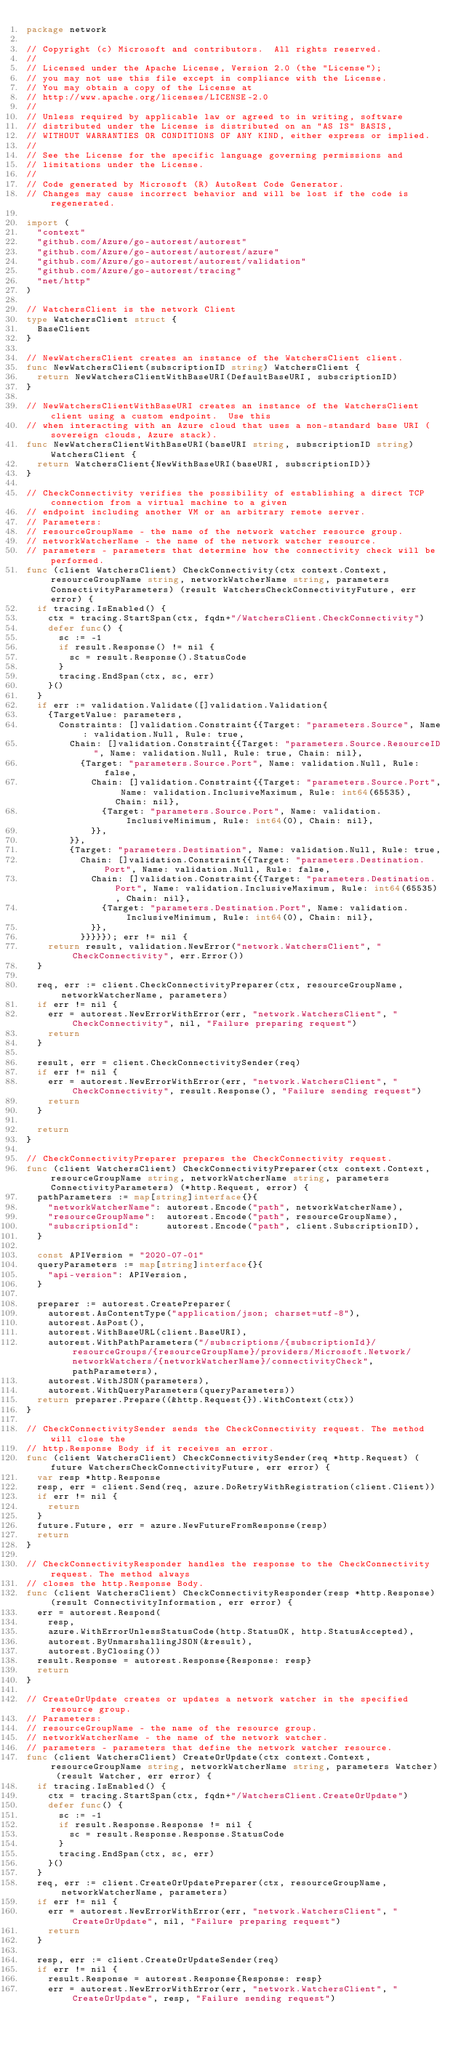<code> <loc_0><loc_0><loc_500><loc_500><_Go_>package network

// Copyright (c) Microsoft and contributors.  All rights reserved.
//
// Licensed under the Apache License, Version 2.0 (the "License");
// you may not use this file except in compliance with the License.
// You may obtain a copy of the License at
// http://www.apache.org/licenses/LICENSE-2.0
//
// Unless required by applicable law or agreed to in writing, software
// distributed under the License is distributed on an "AS IS" BASIS,
// WITHOUT WARRANTIES OR CONDITIONS OF ANY KIND, either express or implied.
//
// See the License for the specific language governing permissions and
// limitations under the License.
//
// Code generated by Microsoft (R) AutoRest Code Generator.
// Changes may cause incorrect behavior and will be lost if the code is regenerated.

import (
	"context"
	"github.com/Azure/go-autorest/autorest"
	"github.com/Azure/go-autorest/autorest/azure"
	"github.com/Azure/go-autorest/autorest/validation"
	"github.com/Azure/go-autorest/tracing"
	"net/http"
)

// WatchersClient is the network Client
type WatchersClient struct {
	BaseClient
}

// NewWatchersClient creates an instance of the WatchersClient client.
func NewWatchersClient(subscriptionID string) WatchersClient {
	return NewWatchersClientWithBaseURI(DefaultBaseURI, subscriptionID)
}

// NewWatchersClientWithBaseURI creates an instance of the WatchersClient client using a custom endpoint.  Use this
// when interacting with an Azure cloud that uses a non-standard base URI (sovereign clouds, Azure stack).
func NewWatchersClientWithBaseURI(baseURI string, subscriptionID string) WatchersClient {
	return WatchersClient{NewWithBaseURI(baseURI, subscriptionID)}
}

// CheckConnectivity verifies the possibility of establishing a direct TCP connection from a virtual machine to a given
// endpoint including another VM or an arbitrary remote server.
// Parameters:
// resourceGroupName - the name of the network watcher resource group.
// networkWatcherName - the name of the network watcher resource.
// parameters - parameters that determine how the connectivity check will be performed.
func (client WatchersClient) CheckConnectivity(ctx context.Context, resourceGroupName string, networkWatcherName string, parameters ConnectivityParameters) (result WatchersCheckConnectivityFuture, err error) {
	if tracing.IsEnabled() {
		ctx = tracing.StartSpan(ctx, fqdn+"/WatchersClient.CheckConnectivity")
		defer func() {
			sc := -1
			if result.Response() != nil {
				sc = result.Response().StatusCode
			}
			tracing.EndSpan(ctx, sc, err)
		}()
	}
	if err := validation.Validate([]validation.Validation{
		{TargetValue: parameters,
			Constraints: []validation.Constraint{{Target: "parameters.Source", Name: validation.Null, Rule: true,
				Chain: []validation.Constraint{{Target: "parameters.Source.ResourceID", Name: validation.Null, Rule: true, Chain: nil},
					{Target: "parameters.Source.Port", Name: validation.Null, Rule: false,
						Chain: []validation.Constraint{{Target: "parameters.Source.Port", Name: validation.InclusiveMaximum, Rule: int64(65535), Chain: nil},
							{Target: "parameters.Source.Port", Name: validation.InclusiveMinimum, Rule: int64(0), Chain: nil},
						}},
				}},
				{Target: "parameters.Destination", Name: validation.Null, Rule: true,
					Chain: []validation.Constraint{{Target: "parameters.Destination.Port", Name: validation.Null, Rule: false,
						Chain: []validation.Constraint{{Target: "parameters.Destination.Port", Name: validation.InclusiveMaximum, Rule: int64(65535), Chain: nil},
							{Target: "parameters.Destination.Port", Name: validation.InclusiveMinimum, Rule: int64(0), Chain: nil},
						}},
					}}}}}); err != nil {
		return result, validation.NewError("network.WatchersClient", "CheckConnectivity", err.Error())
	}

	req, err := client.CheckConnectivityPreparer(ctx, resourceGroupName, networkWatcherName, parameters)
	if err != nil {
		err = autorest.NewErrorWithError(err, "network.WatchersClient", "CheckConnectivity", nil, "Failure preparing request")
		return
	}

	result, err = client.CheckConnectivitySender(req)
	if err != nil {
		err = autorest.NewErrorWithError(err, "network.WatchersClient", "CheckConnectivity", result.Response(), "Failure sending request")
		return
	}

	return
}

// CheckConnectivityPreparer prepares the CheckConnectivity request.
func (client WatchersClient) CheckConnectivityPreparer(ctx context.Context, resourceGroupName string, networkWatcherName string, parameters ConnectivityParameters) (*http.Request, error) {
	pathParameters := map[string]interface{}{
		"networkWatcherName": autorest.Encode("path", networkWatcherName),
		"resourceGroupName":  autorest.Encode("path", resourceGroupName),
		"subscriptionId":     autorest.Encode("path", client.SubscriptionID),
	}

	const APIVersion = "2020-07-01"
	queryParameters := map[string]interface{}{
		"api-version": APIVersion,
	}

	preparer := autorest.CreatePreparer(
		autorest.AsContentType("application/json; charset=utf-8"),
		autorest.AsPost(),
		autorest.WithBaseURL(client.BaseURI),
		autorest.WithPathParameters("/subscriptions/{subscriptionId}/resourceGroups/{resourceGroupName}/providers/Microsoft.Network/networkWatchers/{networkWatcherName}/connectivityCheck", pathParameters),
		autorest.WithJSON(parameters),
		autorest.WithQueryParameters(queryParameters))
	return preparer.Prepare((&http.Request{}).WithContext(ctx))
}

// CheckConnectivitySender sends the CheckConnectivity request. The method will close the
// http.Response Body if it receives an error.
func (client WatchersClient) CheckConnectivitySender(req *http.Request) (future WatchersCheckConnectivityFuture, err error) {
	var resp *http.Response
	resp, err = client.Send(req, azure.DoRetryWithRegistration(client.Client))
	if err != nil {
		return
	}
	future.Future, err = azure.NewFutureFromResponse(resp)
	return
}

// CheckConnectivityResponder handles the response to the CheckConnectivity request. The method always
// closes the http.Response Body.
func (client WatchersClient) CheckConnectivityResponder(resp *http.Response) (result ConnectivityInformation, err error) {
	err = autorest.Respond(
		resp,
		azure.WithErrorUnlessStatusCode(http.StatusOK, http.StatusAccepted),
		autorest.ByUnmarshallingJSON(&result),
		autorest.ByClosing())
	result.Response = autorest.Response{Response: resp}
	return
}

// CreateOrUpdate creates or updates a network watcher in the specified resource group.
// Parameters:
// resourceGroupName - the name of the resource group.
// networkWatcherName - the name of the network watcher.
// parameters - parameters that define the network watcher resource.
func (client WatchersClient) CreateOrUpdate(ctx context.Context, resourceGroupName string, networkWatcherName string, parameters Watcher) (result Watcher, err error) {
	if tracing.IsEnabled() {
		ctx = tracing.StartSpan(ctx, fqdn+"/WatchersClient.CreateOrUpdate")
		defer func() {
			sc := -1
			if result.Response.Response != nil {
				sc = result.Response.Response.StatusCode
			}
			tracing.EndSpan(ctx, sc, err)
		}()
	}
	req, err := client.CreateOrUpdatePreparer(ctx, resourceGroupName, networkWatcherName, parameters)
	if err != nil {
		err = autorest.NewErrorWithError(err, "network.WatchersClient", "CreateOrUpdate", nil, "Failure preparing request")
		return
	}

	resp, err := client.CreateOrUpdateSender(req)
	if err != nil {
		result.Response = autorest.Response{Response: resp}
		err = autorest.NewErrorWithError(err, "network.WatchersClient", "CreateOrUpdate", resp, "Failure sending request")</code> 